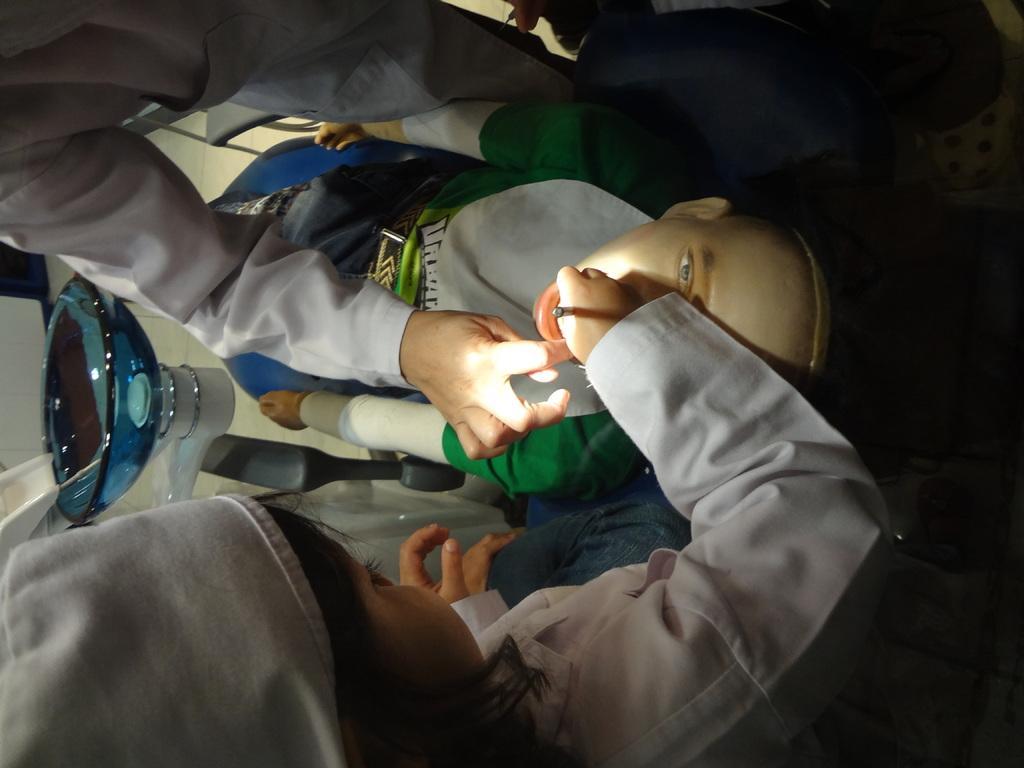How would you summarize this image in a sentence or two? In this image, I can see two people standing and a mannequin lying on a chair. On the left side of the image, It looks a washbasin. 